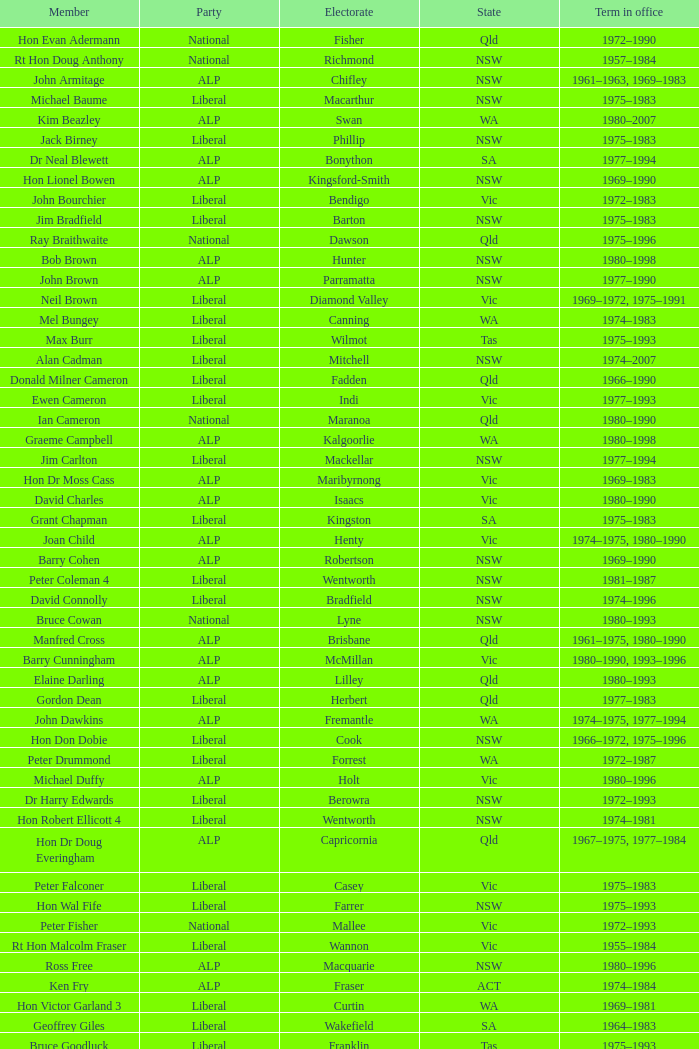When was Hon Les Johnson in office? 1955–1966, 1969–1984. 